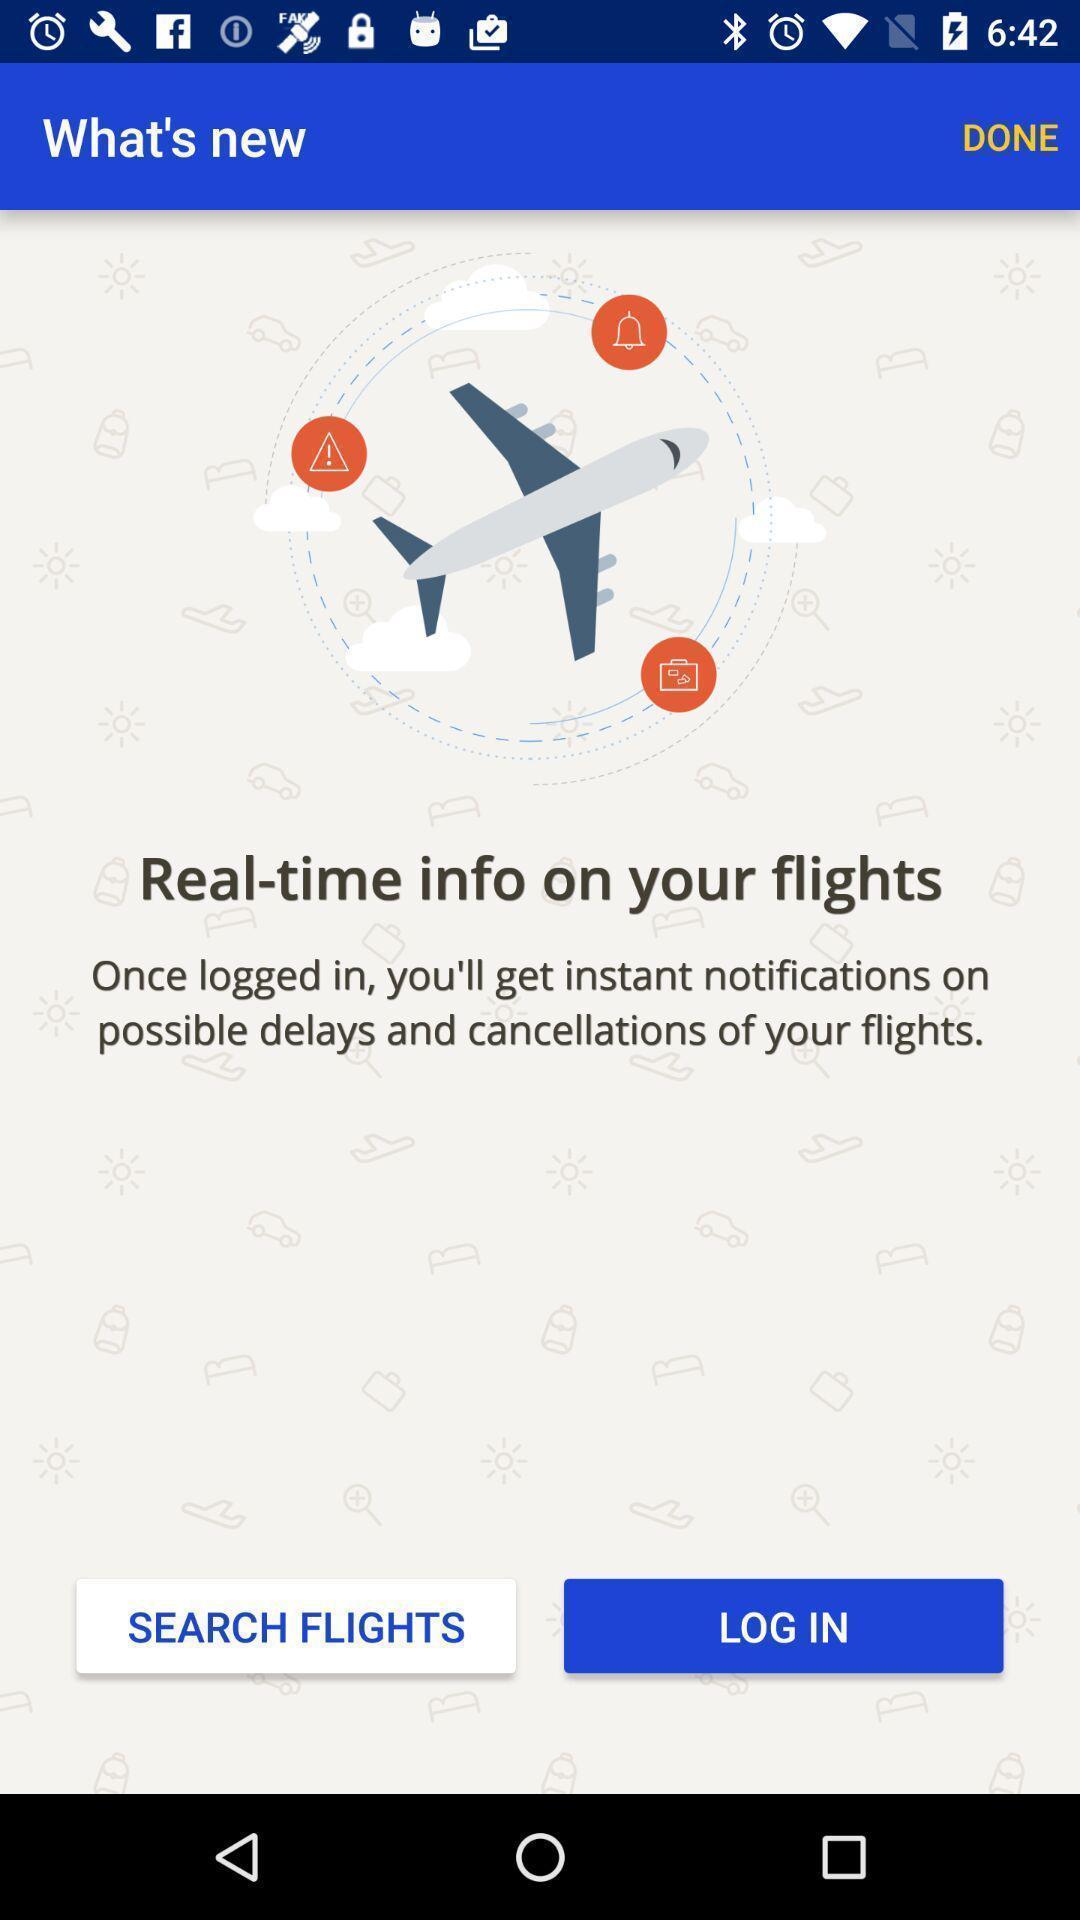What can you discern from this picture? Login page of app to get the flight timings. 